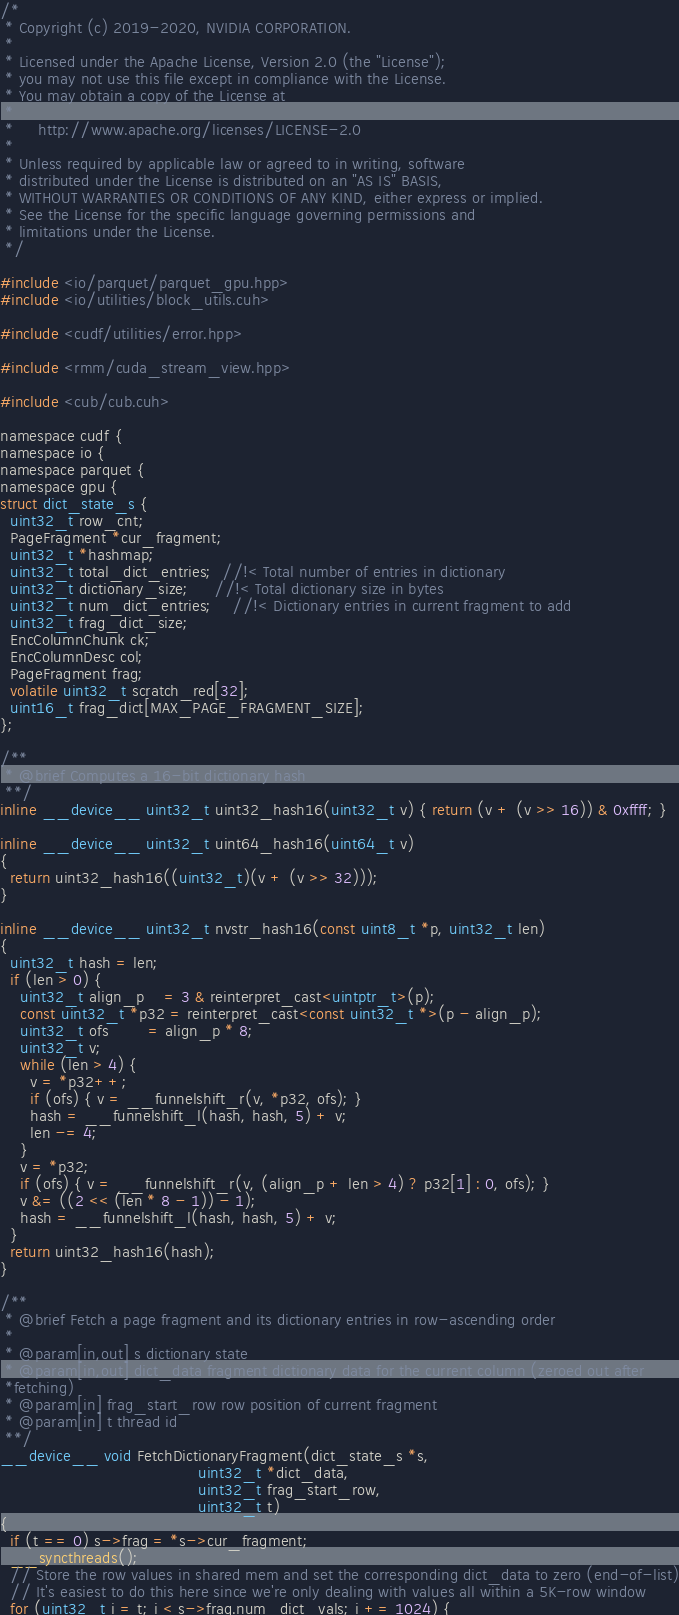Convert code to text. <code><loc_0><loc_0><loc_500><loc_500><_Cuda_>/*
 * Copyright (c) 2019-2020, NVIDIA CORPORATION.
 *
 * Licensed under the Apache License, Version 2.0 (the "License");
 * you may not use this file except in compliance with the License.
 * You may obtain a copy of the License at
 *
 *     http://www.apache.org/licenses/LICENSE-2.0
 *
 * Unless required by applicable law or agreed to in writing, software
 * distributed under the License is distributed on an "AS IS" BASIS,
 * WITHOUT WARRANTIES OR CONDITIONS OF ANY KIND, either express or implied.
 * See the License for the specific language governing permissions and
 * limitations under the License.
 */

#include <io/parquet/parquet_gpu.hpp>
#include <io/utilities/block_utils.cuh>

#include <cudf/utilities/error.hpp>

#include <rmm/cuda_stream_view.hpp>

#include <cub/cub.cuh>

namespace cudf {
namespace io {
namespace parquet {
namespace gpu {
struct dict_state_s {
  uint32_t row_cnt;
  PageFragment *cur_fragment;
  uint32_t *hashmap;
  uint32_t total_dict_entries;  //!< Total number of entries in dictionary
  uint32_t dictionary_size;     //!< Total dictionary size in bytes
  uint32_t num_dict_entries;    //!< Dictionary entries in current fragment to add
  uint32_t frag_dict_size;
  EncColumnChunk ck;
  EncColumnDesc col;
  PageFragment frag;
  volatile uint32_t scratch_red[32];
  uint16_t frag_dict[MAX_PAGE_FRAGMENT_SIZE];
};

/**
 * @brief Computes a 16-bit dictionary hash
 **/
inline __device__ uint32_t uint32_hash16(uint32_t v) { return (v + (v >> 16)) & 0xffff; }

inline __device__ uint32_t uint64_hash16(uint64_t v)
{
  return uint32_hash16((uint32_t)(v + (v >> 32)));
}

inline __device__ uint32_t nvstr_hash16(const uint8_t *p, uint32_t len)
{
  uint32_t hash = len;
  if (len > 0) {
    uint32_t align_p    = 3 & reinterpret_cast<uintptr_t>(p);
    const uint32_t *p32 = reinterpret_cast<const uint32_t *>(p - align_p);
    uint32_t ofs        = align_p * 8;
    uint32_t v;
    while (len > 4) {
      v = *p32++;
      if (ofs) { v = __funnelshift_r(v, *p32, ofs); }
      hash = __funnelshift_l(hash, hash, 5) + v;
      len -= 4;
    }
    v = *p32;
    if (ofs) { v = __funnelshift_r(v, (align_p + len > 4) ? p32[1] : 0, ofs); }
    v &= ((2 << (len * 8 - 1)) - 1);
    hash = __funnelshift_l(hash, hash, 5) + v;
  }
  return uint32_hash16(hash);
}

/**
 * @brief Fetch a page fragment and its dictionary entries in row-ascending order
 *
 * @param[in,out] s dictionary state
 * @param[in,out] dict_data fragment dictionary data for the current column (zeroed out after
 *fetching)
 * @param[in] frag_start_row row position of current fragment
 * @param[in] t thread id
 **/
__device__ void FetchDictionaryFragment(dict_state_s *s,
                                        uint32_t *dict_data,
                                        uint32_t frag_start_row,
                                        uint32_t t)
{
  if (t == 0) s->frag = *s->cur_fragment;
  __syncthreads();
  // Store the row values in shared mem and set the corresponding dict_data to zero (end-of-list)
  // It's easiest to do this here since we're only dealing with values all within a 5K-row window
  for (uint32_t i = t; i < s->frag.num_dict_vals; i += 1024) {</code> 